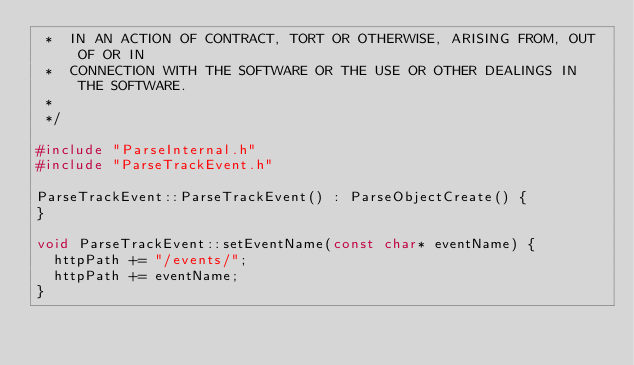<code> <loc_0><loc_0><loc_500><loc_500><_C++_> *  IN AN ACTION OF CONTRACT, TORT OR OTHERWISE, ARISING FROM, OUT OF OR IN
 *  CONNECTION WITH THE SOFTWARE OR THE USE OR OTHER DEALINGS IN THE SOFTWARE.
 *
 */

#include "ParseInternal.h"
#include "ParseTrackEvent.h"

ParseTrackEvent::ParseTrackEvent() : ParseObjectCreate() {
}

void ParseTrackEvent::setEventName(const char* eventName) {
  httpPath += "/events/";
  httpPath += eventName;
}
</code> 